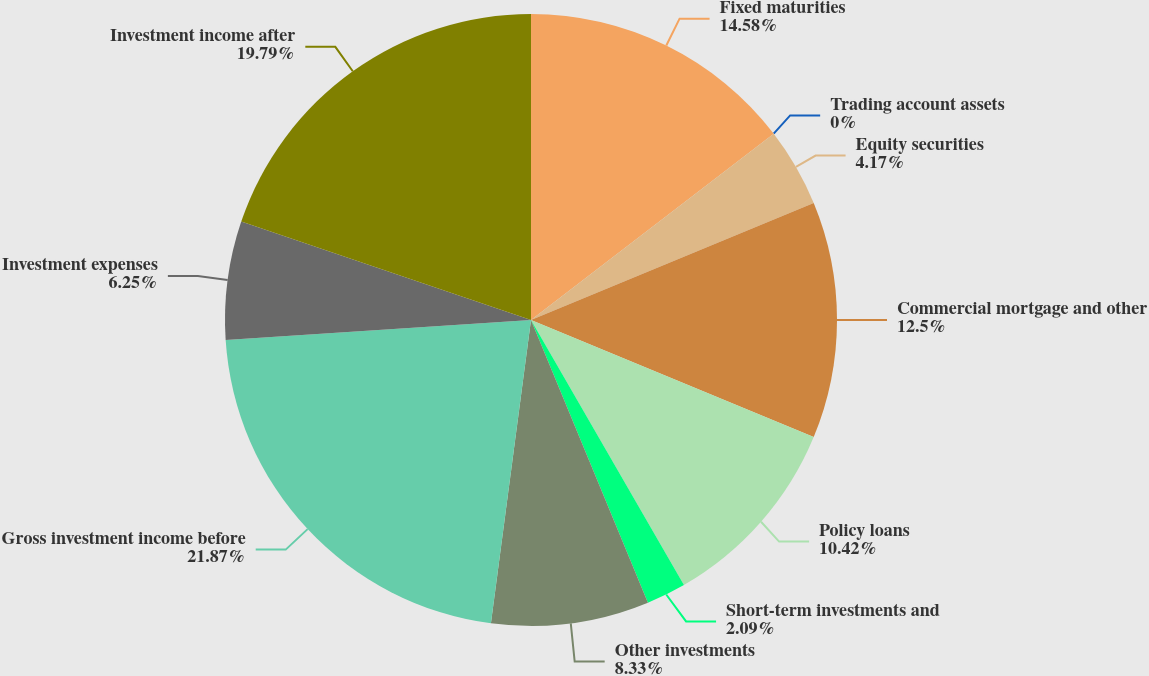Convert chart. <chart><loc_0><loc_0><loc_500><loc_500><pie_chart><fcel>Fixed maturities<fcel>Trading account assets<fcel>Equity securities<fcel>Commercial mortgage and other<fcel>Policy loans<fcel>Short-term investments and<fcel>Other investments<fcel>Gross investment income before<fcel>Investment expenses<fcel>Investment income after<nl><fcel>14.58%<fcel>0.0%<fcel>4.17%<fcel>12.5%<fcel>10.42%<fcel>2.09%<fcel>8.33%<fcel>21.87%<fcel>6.25%<fcel>19.79%<nl></chart> 